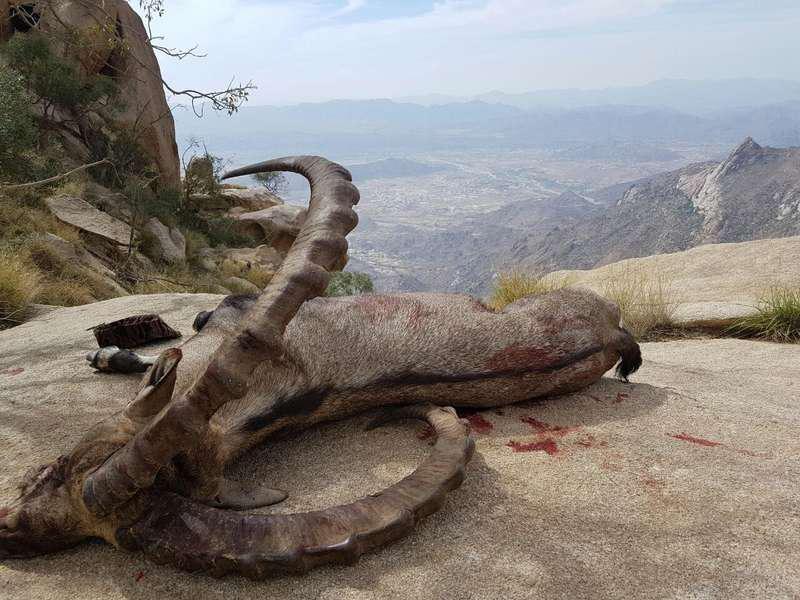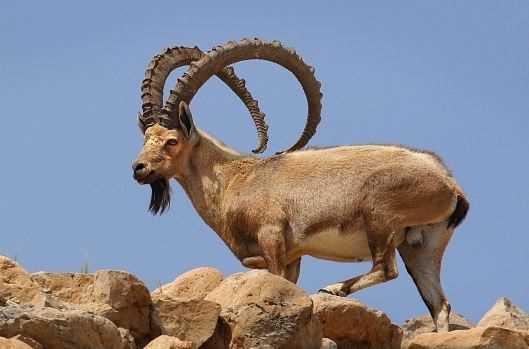The first image is the image on the left, the second image is the image on the right. Examine the images to the left and right. Is the description "There is an animal lying on the ground in one of the images." accurate? Answer yes or no. Yes. 